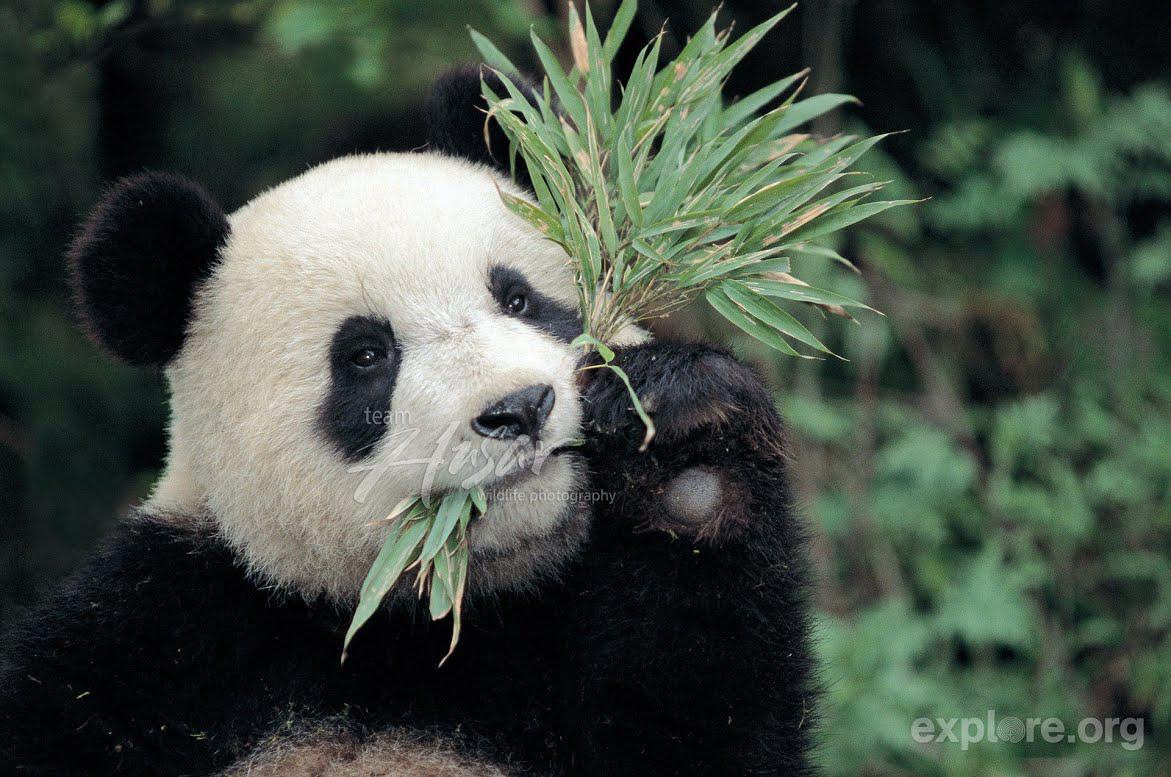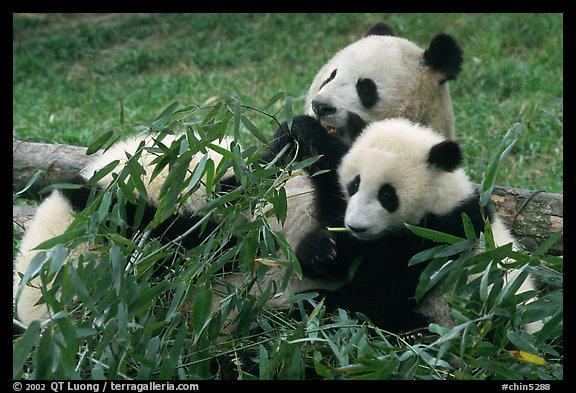The first image is the image on the left, the second image is the image on the right. Given the left and right images, does the statement "There are more than 4 pandas." hold true? Answer yes or no. No. The first image is the image on the left, the second image is the image on the right. Evaluate the accuracy of this statement regarding the images: "The left image contains exactly one panda.". Is it true? Answer yes or no. Yes. 